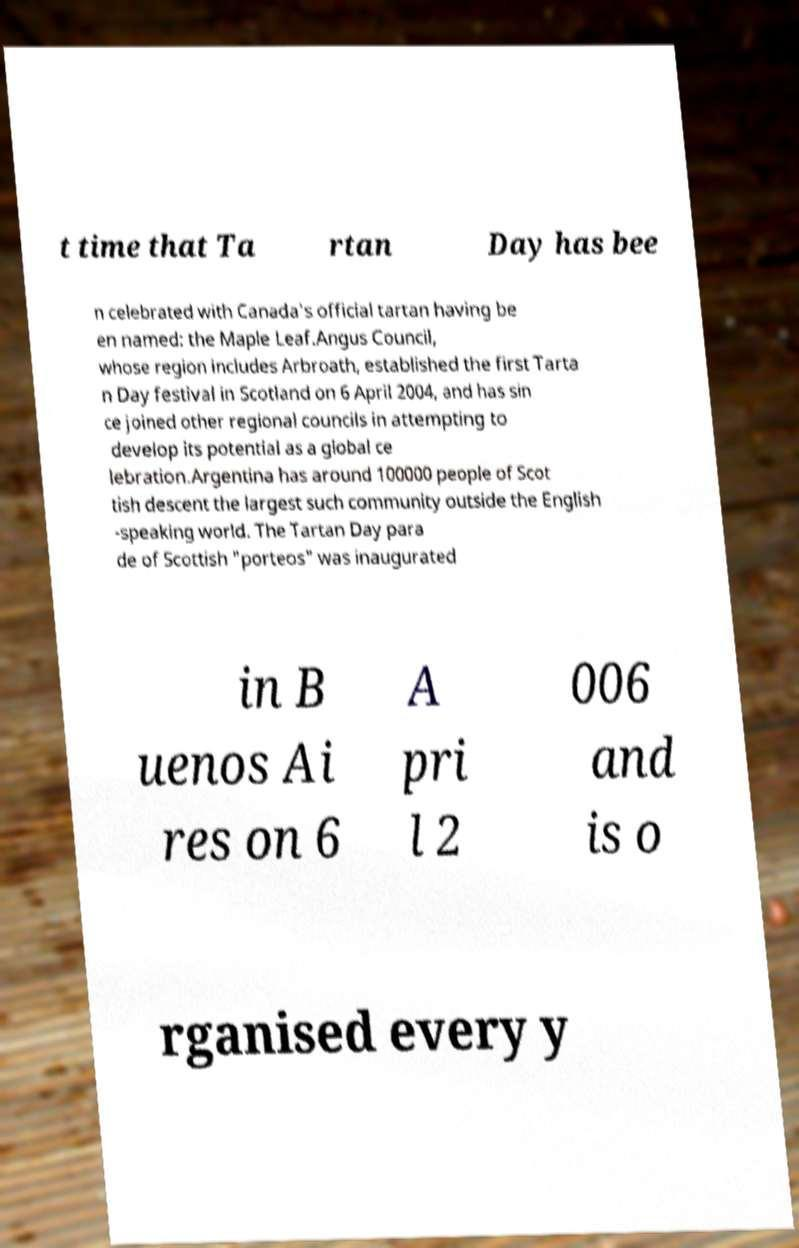Please identify and transcribe the text found in this image. t time that Ta rtan Day has bee n celebrated with Canada's official tartan having be en named: the Maple Leaf.Angus Council, whose region includes Arbroath, established the first Tarta n Day festival in Scotland on 6 April 2004, and has sin ce joined other regional councils in attempting to develop its potential as a global ce lebration.Argentina has around 100000 people of Scot tish descent the largest such community outside the English -speaking world. The Tartan Day para de of Scottish "porteos" was inaugurated in B uenos Ai res on 6 A pri l 2 006 and is o rganised every y 